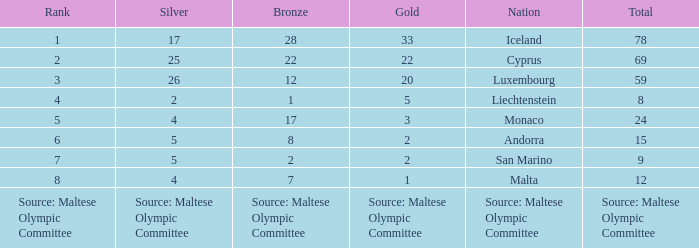What rank is the nation that has a bronze of source: Maltese Olympic Committee? Source: Maltese Olympic Committee. 